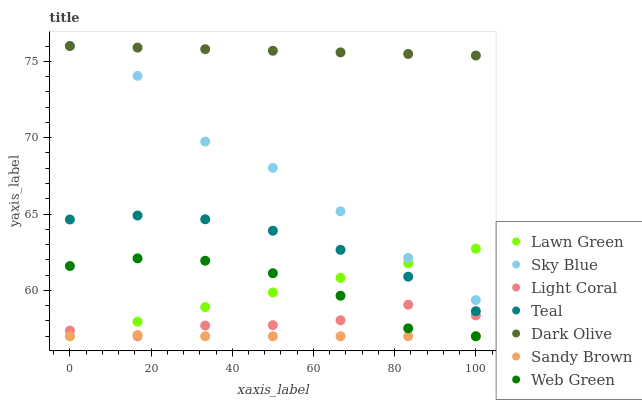Does Sandy Brown have the minimum area under the curve?
Answer yes or no. Yes. Does Dark Olive have the maximum area under the curve?
Answer yes or no. Yes. Does Web Green have the minimum area under the curve?
Answer yes or no. No. Does Web Green have the maximum area under the curve?
Answer yes or no. No. Is Lawn Green the smoothest?
Answer yes or no. Yes. Is Sky Blue the roughest?
Answer yes or no. Yes. Is Dark Olive the smoothest?
Answer yes or no. No. Is Dark Olive the roughest?
Answer yes or no. No. Does Lawn Green have the lowest value?
Answer yes or no. Yes. Does Dark Olive have the lowest value?
Answer yes or no. No. Does Sky Blue have the highest value?
Answer yes or no. Yes. Does Web Green have the highest value?
Answer yes or no. No. Is Light Coral less than Dark Olive?
Answer yes or no. Yes. Is Teal greater than Web Green?
Answer yes or no. Yes. Does Dark Olive intersect Sky Blue?
Answer yes or no. Yes. Is Dark Olive less than Sky Blue?
Answer yes or no. No. Is Dark Olive greater than Sky Blue?
Answer yes or no. No. Does Light Coral intersect Dark Olive?
Answer yes or no. No. 